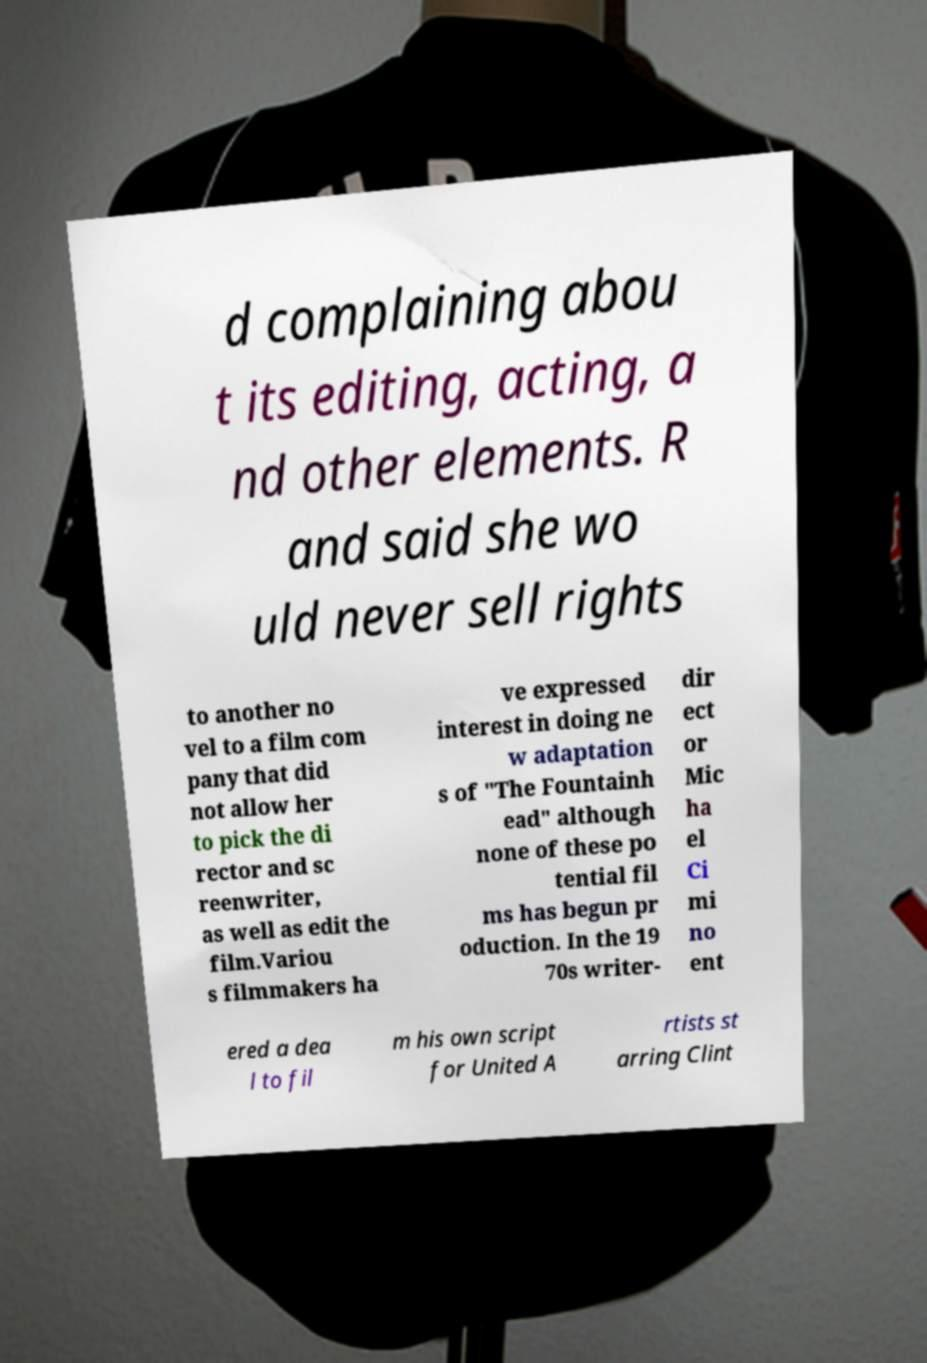What messages or text are displayed in this image? I need them in a readable, typed format. d complaining abou t its editing, acting, a nd other elements. R and said she wo uld never sell rights to another no vel to a film com pany that did not allow her to pick the di rector and sc reenwriter, as well as edit the film.Variou s filmmakers ha ve expressed interest in doing ne w adaptation s of "The Fountainh ead" although none of these po tential fil ms has begun pr oduction. In the 19 70s writer- dir ect or Mic ha el Ci mi no ent ered a dea l to fil m his own script for United A rtists st arring Clint 